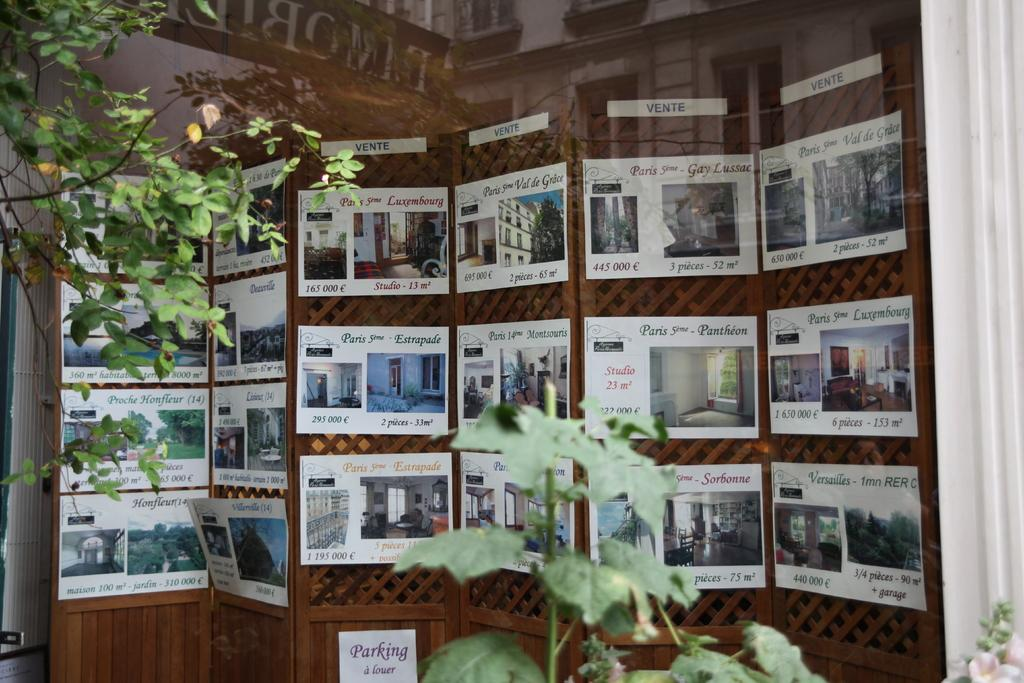What can be seen on the walls in the image? There are posters in the image. What is written or depicted on the posters? There is writing on the posters. What type of vegetation is visible in the image? There are green color leaves visible in the image. What type of invention is being demonstrated in the image? There is no invention being demonstrated in the image; it only features posters with writing and green leaves. What color is the coat worn by the person in the image? There is no person wearing a coat in the image. 